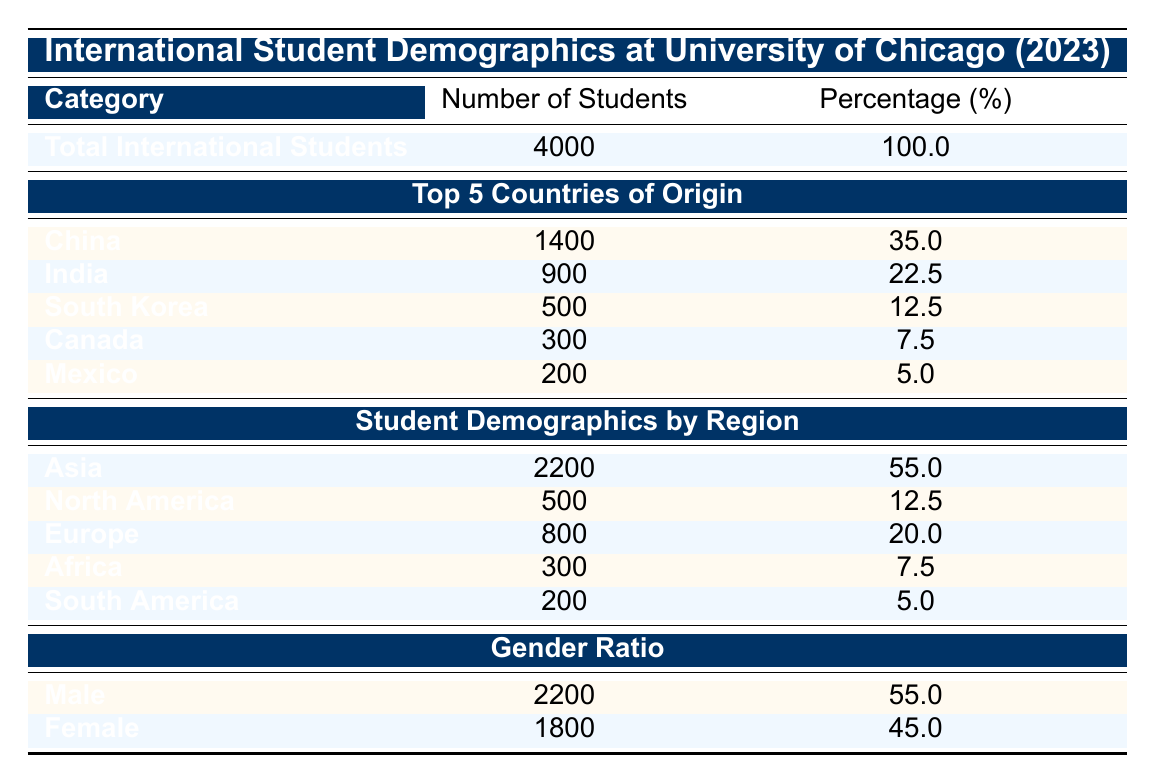What is the total number of international students at the University of Chicago in 2023? The total number of international students is provided directly in the table under "Total International Students," which states there are 4000 students.
Answer: 4000 Which country has the highest number of international students? The table lists the top 5 countries of origin, and China is mentioned as having 1400 students, which is more than any other country.
Answer: China What percentage of international students at the University of Chicago come from Asia? The table indicates that Asia has 2200 students out of a total of 4000. To find the percentage, we calculate (2200/4000)*100 = 55%.
Answer: 55.0 Is the number of international students from Canada greater than that from Mexico? The table shows Canada has 300 students and Mexico has 200 students. Since 300 is greater than 200, the statement is true.
Answer: Yes What is the gender ratio of international students at the University of Chicago? The table provides the number of male and female students, with 2200 males and 1800 females. To find the ratio, males: females = 2200:1800, which simplifies to 11:9.
Answer: 11:9 How many international students are from India compared to those from South Korea? According to the table, there are 900 students from India and 500 from South Korea. The difference in numbers is 900 - 500 = 400 students.
Answer: 400 What percentage of total international students are female? The table indicates there are 1800 females. To find the percentage, we calculate (1800/4000)*100 = 45%.
Answer: 45.0 If we sum the number of students from North America and South America, how many students does that total? The table shows 500 students from North America and 200 from South America. Adding these two gives 500 + 200 = 700.
Answer: 700 Are there more international male students than female students at the University of Chicago? According to the table, there are 2200 males and 1800 females. Since 2200 is greater than 1800, the answer is yes.
Answer: Yes 